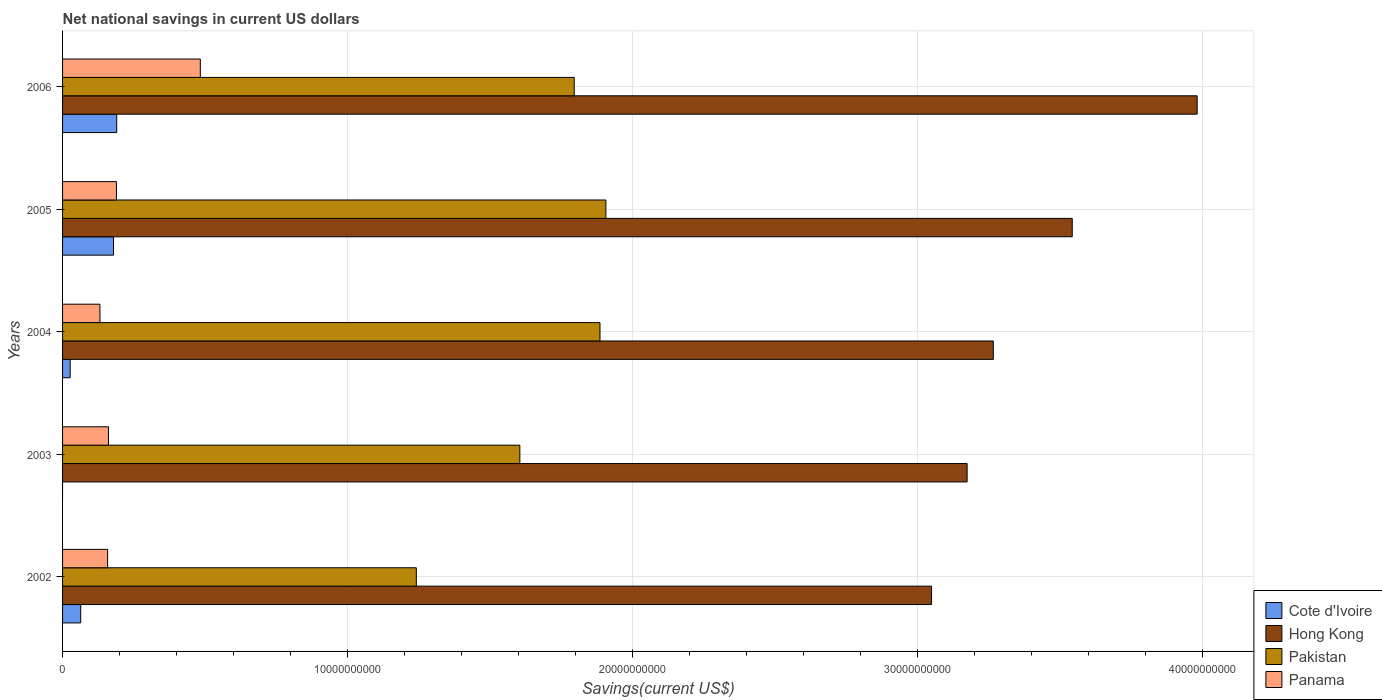How many different coloured bars are there?
Offer a terse response. 4. Are the number of bars per tick equal to the number of legend labels?
Give a very brief answer. No. Are the number of bars on each tick of the Y-axis equal?
Make the answer very short. No. How many bars are there on the 5th tick from the top?
Provide a succinct answer. 4. How many bars are there on the 3rd tick from the bottom?
Your answer should be very brief. 4. What is the label of the 1st group of bars from the top?
Give a very brief answer. 2006. In how many cases, is the number of bars for a given year not equal to the number of legend labels?
Offer a terse response. 1. What is the net national savings in Cote d'Ivoire in 2004?
Ensure brevity in your answer.  2.67e+08. Across all years, what is the maximum net national savings in Hong Kong?
Keep it short and to the point. 3.98e+1. Across all years, what is the minimum net national savings in Panama?
Your answer should be compact. 1.31e+09. What is the total net national savings in Panama in the graph?
Offer a very short reply. 1.12e+1. What is the difference between the net national savings in Panama in 2002 and that in 2003?
Offer a very short reply. -3.04e+07. What is the difference between the net national savings in Cote d'Ivoire in 2005 and the net national savings in Pakistan in 2003?
Make the answer very short. -1.43e+1. What is the average net national savings in Hong Kong per year?
Your answer should be very brief. 3.40e+1. In the year 2005, what is the difference between the net national savings in Pakistan and net national savings in Hong Kong?
Your answer should be very brief. -1.64e+1. In how many years, is the net national savings in Panama greater than 24000000000 US$?
Ensure brevity in your answer.  0. What is the ratio of the net national savings in Pakistan in 2005 to that in 2006?
Your answer should be very brief. 1.06. Is the net national savings in Pakistan in 2005 less than that in 2006?
Ensure brevity in your answer.  No. Is the difference between the net national savings in Pakistan in 2005 and 2006 greater than the difference between the net national savings in Hong Kong in 2005 and 2006?
Provide a short and direct response. Yes. What is the difference between the highest and the second highest net national savings in Panama?
Keep it short and to the point. 2.94e+09. What is the difference between the highest and the lowest net national savings in Cote d'Ivoire?
Give a very brief answer. 1.90e+09. Is it the case that in every year, the sum of the net national savings in Hong Kong and net national savings in Panama is greater than the sum of net national savings in Pakistan and net national savings in Cote d'Ivoire?
Make the answer very short. No. How many bars are there?
Offer a very short reply. 19. Are all the bars in the graph horizontal?
Make the answer very short. Yes. How many years are there in the graph?
Your response must be concise. 5. What is the difference between two consecutive major ticks on the X-axis?
Ensure brevity in your answer.  1.00e+1. Are the values on the major ticks of X-axis written in scientific E-notation?
Give a very brief answer. No. Does the graph contain any zero values?
Offer a very short reply. Yes. Does the graph contain grids?
Provide a short and direct response. Yes. How are the legend labels stacked?
Ensure brevity in your answer.  Vertical. What is the title of the graph?
Offer a very short reply. Net national savings in current US dollars. What is the label or title of the X-axis?
Offer a terse response. Savings(current US$). What is the Savings(current US$) of Cote d'Ivoire in 2002?
Provide a succinct answer. 6.36e+08. What is the Savings(current US$) in Hong Kong in 2002?
Give a very brief answer. 3.05e+1. What is the Savings(current US$) of Pakistan in 2002?
Offer a terse response. 1.24e+1. What is the Savings(current US$) in Panama in 2002?
Make the answer very short. 1.58e+09. What is the Savings(current US$) in Cote d'Ivoire in 2003?
Provide a succinct answer. 0. What is the Savings(current US$) in Hong Kong in 2003?
Provide a short and direct response. 3.17e+1. What is the Savings(current US$) of Pakistan in 2003?
Your answer should be very brief. 1.60e+1. What is the Savings(current US$) of Panama in 2003?
Provide a succinct answer. 1.61e+09. What is the Savings(current US$) of Cote d'Ivoire in 2004?
Provide a short and direct response. 2.67e+08. What is the Savings(current US$) of Hong Kong in 2004?
Make the answer very short. 3.27e+1. What is the Savings(current US$) in Pakistan in 2004?
Your answer should be compact. 1.89e+1. What is the Savings(current US$) in Panama in 2004?
Keep it short and to the point. 1.31e+09. What is the Savings(current US$) in Cote d'Ivoire in 2005?
Your answer should be compact. 1.79e+09. What is the Savings(current US$) of Hong Kong in 2005?
Ensure brevity in your answer.  3.54e+1. What is the Savings(current US$) in Pakistan in 2005?
Provide a short and direct response. 1.91e+1. What is the Savings(current US$) in Panama in 2005?
Provide a succinct answer. 1.89e+09. What is the Savings(current US$) of Cote d'Ivoire in 2006?
Ensure brevity in your answer.  1.90e+09. What is the Savings(current US$) in Hong Kong in 2006?
Ensure brevity in your answer.  3.98e+1. What is the Savings(current US$) in Pakistan in 2006?
Make the answer very short. 1.79e+1. What is the Savings(current US$) of Panama in 2006?
Your answer should be very brief. 4.83e+09. Across all years, what is the maximum Savings(current US$) in Cote d'Ivoire?
Offer a very short reply. 1.90e+09. Across all years, what is the maximum Savings(current US$) in Hong Kong?
Offer a terse response. 3.98e+1. Across all years, what is the maximum Savings(current US$) of Pakistan?
Make the answer very short. 1.91e+1. Across all years, what is the maximum Savings(current US$) in Panama?
Provide a short and direct response. 4.83e+09. Across all years, what is the minimum Savings(current US$) of Cote d'Ivoire?
Offer a very short reply. 0. Across all years, what is the minimum Savings(current US$) in Hong Kong?
Provide a short and direct response. 3.05e+1. Across all years, what is the minimum Savings(current US$) of Pakistan?
Offer a very short reply. 1.24e+1. Across all years, what is the minimum Savings(current US$) of Panama?
Your answer should be compact. 1.31e+09. What is the total Savings(current US$) of Cote d'Ivoire in the graph?
Give a very brief answer. 4.59e+09. What is the total Savings(current US$) of Hong Kong in the graph?
Provide a short and direct response. 1.70e+11. What is the total Savings(current US$) in Pakistan in the graph?
Offer a very short reply. 8.43e+1. What is the total Savings(current US$) of Panama in the graph?
Ensure brevity in your answer.  1.12e+1. What is the difference between the Savings(current US$) in Hong Kong in 2002 and that in 2003?
Give a very brief answer. -1.25e+09. What is the difference between the Savings(current US$) of Pakistan in 2002 and that in 2003?
Offer a very short reply. -3.63e+09. What is the difference between the Savings(current US$) of Panama in 2002 and that in 2003?
Provide a succinct answer. -3.04e+07. What is the difference between the Savings(current US$) of Cote d'Ivoire in 2002 and that in 2004?
Your answer should be compact. 3.69e+08. What is the difference between the Savings(current US$) of Hong Kong in 2002 and that in 2004?
Keep it short and to the point. -2.17e+09. What is the difference between the Savings(current US$) of Pakistan in 2002 and that in 2004?
Your answer should be very brief. -6.44e+09. What is the difference between the Savings(current US$) of Panama in 2002 and that in 2004?
Provide a succinct answer. 2.68e+08. What is the difference between the Savings(current US$) of Cote d'Ivoire in 2002 and that in 2005?
Offer a terse response. -1.15e+09. What is the difference between the Savings(current US$) of Hong Kong in 2002 and that in 2005?
Make the answer very short. -4.93e+09. What is the difference between the Savings(current US$) in Pakistan in 2002 and that in 2005?
Ensure brevity in your answer.  -6.65e+09. What is the difference between the Savings(current US$) in Panama in 2002 and that in 2005?
Offer a terse response. -3.10e+08. What is the difference between the Savings(current US$) in Cote d'Ivoire in 2002 and that in 2006?
Offer a very short reply. -1.26e+09. What is the difference between the Savings(current US$) of Hong Kong in 2002 and that in 2006?
Keep it short and to the point. -9.32e+09. What is the difference between the Savings(current US$) of Pakistan in 2002 and that in 2006?
Make the answer very short. -5.54e+09. What is the difference between the Savings(current US$) in Panama in 2002 and that in 2006?
Offer a terse response. -3.25e+09. What is the difference between the Savings(current US$) in Hong Kong in 2003 and that in 2004?
Your response must be concise. -9.20e+08. What is the difference between the Savings(current US$) in Pakistan in 2003 and that in 2004?
Your answer should be very brief. -2.81e+09. What is the difference between the Savings(current US$) of Panama in 2003 and that in 2004?
Offer a very short reply. 2.99e+08. What is the difference between the Savings(current US$) in Hong Kong in 2003 and that in 2005?
Keep it short and to the point. -3.69e+09. What is the difference between the Savings(current US$) of Pakistan in 2003 and that in 2005?
Keep it short and to the point. -3.02e+09. What is the difference between the Savings(current US$) of Panama in 2003 and that in 2005?
Make the answer very short. -2.80e+08. What is the difference between the Savings(current US$) of Hong Kong in 2003 and that in 2006?
Give a very brief answer. -8.07e+09. What is the difference between the Savings(current US$) in Pakistan in 2003 and that in 2006?
Provide a succinct answer. -1.91e+09. What is the difference between the Savings(current US$) of Panama in 2003 and that in 2006?
Your answer should be very brief. -3.22e+09. What is the difference between the Savings(current US$) of Cote d'Ivoire in 2004 and that in 2005?
Provide a succinct answer. -1.52e+09. What is the difference between the Savings(current US$) in Hong Kong in 2004 and that in 2005?
Provide a succinct answer. -2.77e+09. What is the difference between the Savings(current US$) in Pakistan in 2004 and that in 2005?
Your response must be concise. -2.06e+08. What is the difference between the Savings(current US$) in Panama in 2004 and that in 2005?
Offer a very short reply. -5.78e+08. What is the difference between the Savings(current US$) in Cote d'Ivoire in 2004 and that in 2006?
Keep it short and to the point. -1.63e+09. What is the difference between the Savings(current US$) of Hong Kong in 2004 and that in 2006?
Your response must be concise. -7.15e+09. What is the difference between the Savings(current US$) of Pakistan in 2004 and that in 2006?
Keep it short and to the point. 9.04e+08. What is the difference between the Savings(current US$) of Panama in 2004 and that in 2006?
Offer a terse response. -3.52e+09. What is the difference between the Savings(current US$) of Cote d'Ivoire in 2005 and that in 2006?
Your response must be concise. -1.12e+08. What is the difference between the Savings(current US$) of Hong Kong in 2005 and that in 2006?
Your answer should be compact. -4.38e+09. What is the difference between the Savings(current US$) of Pakistan in 2005 and that in 2006?
Provide a succinct answer. 1.11e+09. What is the difference between the Savings(current US$) of Panama in 2005 and that in 2006?
Offer a terse response. -2.94e+09. What is the difference between the Savings(current US$) in Cote d'Ivoire in 2002 and the Savings(current US$) in Hong Kong in 2003?
Your response must be concise. -3.11e+1. What is the difference between the Savings(current US$) of Cote d'Ivoire in 2002 and the Savings(current US$) of Pakistan in 2003?
Make the answer very short. -1.54e+1. What is the difference between the Savings(current US$) of Cote d'Ivoire in 2002 and the Savings(current US$) of Panama in 2003?
Your response must be concise. -9.75e+08. What is the difference between the Savings(current US$) in Hong Kong in 2002 and the Savings(current US$) in Pakistan in 2003?
Provide a succinct answer. 1.44e+1. What is the difference between the Savings(current US$) of Hong Kong in 2002 and the Savings(current US$) of Panama in 2003?
Give a very brief answer. 2.89e+1. What is the difference between the Savings(current US$) of Pakistan in 2002 and the Savings(current US$) of Panama in 2003?
Offer a terse response. 1.08e+1. What is the difference between the Savings(current US$) in Cote d'Ivoire in 2002 and the Savings(current US$) in Hong Kong in 2004?
Ensure brevity in your answer.  -3.20e+1. What is the difference between the Savings(current US$) of Cote d'Ivoire in 2002 and the Savings(current US$) of Pakistan in 2004?
Your answer should be very brief. -1.82e+1. What is the difference between the Savings(current US$) in Cote d'Ivoire in 2002 and the Savings(current US$) in Panama in 2004?
Provide a short and direct response. -6.76e+08. What is the difference between the Savings(current US$) of Hong Kong in 2002 and the Savings(current US$) of Pakistan in 2004?
Provide a short and direct response. 1.16e+1. What is the difference between the Savings(current US$) of Hong Kong in 2002 and the Savings(current US$) of Panama in 2004?
Provide a succinct answer. 2.92e+1. What is the difference between the Savings(current US$) of Pakistan in 2002 and the Savings(current US$) of Panama in 2004?
Provide a short and direct response. 1.11e+1. What is the difference between the Savings(current US$) of Cote d'Ivoire in 2002 and the Savings(current US$) of Hong Kong in 2005?
Provide a succinct answer. -3.48e+1. What is the difference between the Savings(current US$) in Cote d'Ivoire in 2002 and the Savings(current US$) in Pakistan in 2005?
Ensure brevity in your answer.  -1.84e+1. What is the difference between the Savings(current US$) of Cote d'Ivoire in 2002 and the Savings(current US$) of Panama in 2005?
Your response must be concise. -1.25e+09. What is the difference between the Savings(current US$) in Hong Kong in 2002 and the Savings(current US$) in Pakistan in 2005?
Keep it short and to the point. 1.14e+1. What is the difference between the Savings(current US$) in Hong Kong in 2002 and the Savings(current US$) in Panama in 2005?
Provide a succinct answer. 2.86e+1. What is the difference between the Savings(current US$) in Pakistan in 2002 and the Savings(current US$) in Panama in 2005?
Make the answer very short. 1.05e+1. What is the difference between the Savings(current US$) of Cote d'Ivoire in 2002 and the Savings(current US$) of Hong Kong in 2006?
Offer a very short reply. -3.92e+1. What is the difference between the Savings(current US$) in Cote d'Ivoire in 2002 and the Savings(current US$) in Pakistan in 2006?
Your response must be concise. -1.73e+1. What is the difference between the Savings(current US$) in Cote d'Ivoire in 2002 and the Savings(current US$) in Panama in 2006?
Ensure brevity in your answer.  -4.20e+09. What is the difference between the Savings(current US$) of Hong Kong in 2002 and the Savings(current US$) of Pakistan in 2006?
Provide a short and direct response. 1.25e+1. What is the difference between the Savings(current US$) of Hong Kong in 2002 and the Savings(current US$) of Panama in 2006?
Provide a short and direct response. 2.57e+1. What is the difference between the Savings(current US$) of Pakistan in 2002 and the Savings(current US$) of Panama in 2006?
Your answer should be very brief. 7.58e+09. What is the difference between the Savings(current US$) in Hong Kong in 2003 and the Savings(current US$) in Pakistan in 2004?
Make the answer very short. 1.29e+1. What is the difference between the Savings(current US$) of Hong Kong in 2003 and the Savings(current US$) of Panama in 2004?
Your response must be concise. 3.04e+1. What is the difference between the Savings(current US$) in Pakistan in 2003 and the Savings(current US$) in Panama in 2004?
Offer a very short reply. 1.47e+1. What is the difference between the Savings(current US$) in Hong Kong in 2003 and the Savings(current US$) in Pakistan in 2005?
Your response must be concise. 1.27e+1. What is the difference between the Savings(current US$) of Hong Kong in 2003 and the Savings(current US$) of Panama in 2005?
Offer a terse response. 2.98e+1. What is the difference between the Savings(current US$) of Pakistan in 2003 and the Savings(current US$) of Panama in 2005?
Provide a succinct answer. 1.42e+1. What is the difference between the Savings(current US$) in Hong Kong in 2003 and the Savings(current US$) in Pakistan in 2006?
Ensure brevity in your answer.  1.38e+1. What is the difference between the Savings(current US$) in Hong Kong in 2003 and the Savings(current US$) in Panama in 2006?
Your answer should be very brief. 2.69e+1. What is the difference between the Savings(current US$) of Pakistan in 2003 and the Savings(current US$) of Panama in 2006?
Provide a succinct answer. 1.12e+1. What is the difference between the Savings(current US$) in Cote d'Ivoire in 2004 and the Savings(current US$) in Hong Kong in 2005?
Offer a terse response. -3.52e+1. What is the difference between the Savings(current US$) in Cote d'Ivoire in 2004 and the Savings(current US$) in Pakistan in 2005?
Ensure brevity in your answer.  -1.88e+1. What is the difference between the Savings(current US$) of Cote d'Ivoire in 2004 and the Savings(current US$) of Panama in 2005?
Provide a succinct answer. -1.62e+09. What is the difference between the Savings(current US$) in Hong Kong in 2004 and the Savings(current US$) in Pakistan in 2005?
Your answer should be very brief. 1.36e+1. What is the difference between the Savings(current US$) in Hong Kong in 2004 and the Savings(current US$) in Panama in 2005?
Your answer should be compact. 3.08e+1. What is the difference between the Savings(current US$) of Pakistan in 2004 and the Savings(current US$) of Panama in 2005?
Offer a very short reply. 1.70e+1. What is the difference between the Savings(current US$) of Cote d'Ivoire in 2004 and the Savings(current US$) of Hong Kong in 2006?
Give a very brief answer. -3.95e+1. What is the difference between the Savings(current US$) of Cote d'Ivoire in 2004 and the Savings(current US$) of Pakistan in 2006?
Give a very brief answer. -1.77e+1. What is the difference between the Savings(current US$) in Cote d'Ivoire in 2004 and the Savings(current US$) in Panama in 2006?
Offer a very short reply. -4.56e+09. What is the difference between the Savings(current US$) in Hong Kong in 2004 and the Savings(current US$) in Pakistan in 2006?
Give a very brief answer. 1.47e+1. What is the difference between the Savings(current US$) in Hong Kong in 2004 and the Savings(current US$) in Panama in 2006?
Make the answer very short. 2.78e+1. What is the difference between the Savings(current US$) of Pakistan in 2004 and the Savings(current US$) of Panama in 2006?
Offer a very short reply. 1.40e+1. What is the difference between the Savings(current US$) of Cote d'Ivoire in 2005 and the Savings(current US$) of Hong Kong in 2006?
Provide a succinct answer. -3.80e+1. What is the difference between the Savings(current US$) in Cote d'Ivoire in 2005 and the Savings(current US$) in Pakistan in 2006?
Your answer should be very brief. -1.62e+1. What is the difference between the Savings(current US$) of Cote d'Ivoire in 2005 and the Savings(current US$) of Panama in 2006?
Your answer should be very brief. -3.04e+09. What is the difference between the Savings(current US$) in Hong Kong in 2005 and the Savings(current US$) in Pakistan in 2006?
Provide a succinct answer. 1.75e+1. What is the difference between the Savings(current US$) of Hong Kong in 2005 and the Savings(current US$) of Panama in 2006?
Offer a terse response. 3.06e+1. What is the difference between the Savings(current US$) in Pakistan in 2005 and the Savings(current US$) in Panama in 2006?
Your answer should be compact. 1.42e+1. What is the average Savings(current US$) of Cote d'Ivoire per year?
Ensure brevity in your answer.  9.18e+08. What is the average Savings(current US$) in Hong Kong per year?
Your response must be concise. 3.40e+1. What is the average Savings(current US$) of Pakistan per year?
Your answer should be compact. 1.69e+1. What is the average Savings(current US$) in Panama per year?
Make the answer very short. 2.24e+09. In the year 2002, what is the difference between the Savings(current US$) in Cote d'Ivoire and Savings(current US$) in Hong Kong?
Your answer should be compact. -2.98e+1. In the year 2002, what is the difference between the Savings(current US$) of Cote d'Ivoire and Savings(current US$) of Pakistan?
Ensure brevity in your answer.  -1.18e+1. In the year 2002, what is the difference between the Savings(current US$) in Cote d'Ivoire and Savings(current US$) in Panama?
Give a very brief answer. -9.44e+08. In the year 2002, what is the difference between the Savings(current US$) in Hong Kong and Savings(current US$) in Pakistan?
Offer a terse response. 1.81e+1. In the year 2002, what is the difference between the Savings(current US$) in Hong Kong and Savings(current US$) in Panama?
Ensure brevity in your answer.  2.89e+1. In the year 2002, what is the difference between the Savings(current US$) of Pakistan and Savings(current US$) of Panama?
Keep it short and to the point. 1.08e+1. In the year 2003, what is the difference between the Savings(current US$) of Hong Kong and Savings(current US$) of Pakistan?
Your answer should be very brief. 1.57e+1. In the year 2003, what is the difference between the Savings(current US$) of Hong Kong and Savings(current US$) of Panama?
Ensure brevity in your answer.  3.01e+1. In the year 2003, what is the difference between the Savings(current US$) in Pakistan and Savings(current US$) in Panama?
Provide a short and direct response. 1.44e+1. In the year 2004, what is the difference between the Savings(current US$) of Cote d'Ivoire and Savings(current US$) of Hong Kong?
Provide a succinct answer. -3.24e+1. In the year 2004, what is the difference between the Savings(current US$) of Cote d'Ivoire and Savings(current US$) of Pakistan?
Offer a terse response. -1.86e+1. In the year 2004, what is the difference between the Savings(current US$) in Cote d'Ivoire and Savings(current US$) in Panama?
Your answer should be compact. -1.04e+09. In the year 2004, what is the difference between the Savings(current US$) in Hong Kong and Savings(current US$) in Pakistan?
Offer a terse response. 1.38e+1. In the year 2004, what is the difference between the Savings(current US$) of Hong Kong and Savings(current US$) of Panama?
Keep it short and to the point. 3.13e+1. In the year 2004, what is the difference between the Savings(current US$) of Pakistan and Savings(current US$) of Panama?
Your answer should be compact. 1.75e+1. In the year 2005, what is the difference between the Savings(current US$) in Cote d'Ivoire and Savings(current US$) in Hong Kong?
Your answer should be very brief. -3.36e+1. In the year 2005, what is the difference between the Savings(current US$) of Cote d'Ivoire and Savings(current US$) of Pakistan?
Offer a terse response. -1.73e+1. In the year 2005, what is the difference between the Savings(current US$) in Cote d'Ivoire and Savings(current US$) in Panama?
Keep it short and to the point. -1.03e+08. In the year 2005, what is the difference between the Savings(current US$) in Hong Kong and Savings(current US$) in Pakistan?
Offer a very short reply. 1.64e+1. In the year 2005, what is the difference between the Savings(current US$) of Hong Kong and Savings(current US$) of Panama?
Provide a short and direct response. 3.35e+1. In the year 2005, what is the difference between the Savings(current US$) of Pakistan and Savings(current US$) of Panama?
Offer a terse response. 1.72e+1. In the year 2006, what is the difference between the Savings(current US$) in Cote d'Ivoire and Savings(current US$) in Hong Kong?
Keep it short and to the point. -3.79e+1. In the year 2006, what is the difference between the Savings(current US$) of Cote d'Ivoire and Savings(current US$) of Pakistan?
Provide a succinct answer. -1.60e+1. In the year 2006, what is the difference between the Savings(current US$) of Cote d'Ivoire and Savings(current US$) of Panama?
Your answer should be very brief. -2.93e+09. In the year 2006, what is the difference between the Savings(current US$) in Hong Kong and Savings(current US$) in Pakistan?
Offer a very short reply. 2.19e+1. In the year 2006, what is the difference between the Savings(current US$) in Hong Kong and Savings(current US$) in Panama?
Provide a short and direct response. 3.50e+1. In the year 2006, what is the difference between the Savings(current US$) of Pakistan and Savings(current US$) of Panama?
Your answer should be compact. 1.31e+1. What is the ratio of the Savings(current US$) of Hong Kong in 2002 to that in 2003?
Offer a terse response. 0.96. What is the ratio of the Savings(current US$) of Pakistan in 2002 to that in 2003?
Make the answer very short. 0.77. What is the ratio of the Savings(current US$) of Panama in 2002 to that in 2003?
Your answer should be very brief. 0.98. What is the ratio of the Savings(current US$) of Cote d'Ivoire in 2002 to that in 2004?
Provide a short and direct response. 2.38. What is the ratio of the Savings(current US$) of Hong Kong in 2002 to that in 2004?
Ensure brevity in your answer.  0.93. What is the ratio of the Savings(current US$) of Pakistan in 2002 to that in 2004?
Keep it short and to the point. 0.66. What is the ratio of the Savings(current US$) in Panama in 2002 to that in 2004?
Ensure brevity in your answer.  1.2. What is the ratio of the Savings(current US$) in Cote d'Ivoire in 2002 to that in 2005?
Provide a short and direct response. 0.36. What is the ratio of the Savings(current US$) in Hong Kong in 2002 to that in 2005?
Provide a short and direct response. 0.86. What is the ratio of the Savings(current US$) in Pakistan in 2002 to that in 2005?
Provide a succinct answer. 0.65. What is the ratio of the Savings(current US$) of Panama in 2002 to that in 2005?
Offer a very short reply. 0.84. What is the ratio of the Savings(current US$) of Cote d'Ivoire in 2002 to that in 2006?
Offer a terse response. 0.33. What is the ratio of the Savings(current US$) in Hong Kong in 2002 to that in 2006?
Make the answer very short. 0.77. What is the ratio of the Savings(current US$) of Pakistan in 2002 to that in 2006?
Your answer should be compact. 0.69. What is the ratio of the Savings(current US$) of Panama in 2002 to that in 2006?
Make the answer very short. 0.33. What is the ratio of the Savings(current US$) in Hong Kong in 2003 to that in 2004?
Provide a short and direct response. 0.97. What is the ratio of the Savings(current US$) of Pakistan in 2003 to that in 2004?
Your answer should be very brief. 0.85. What is the ratio of the Savings(current US$) of Panama in 2003 to that in 2004?
Keep it short and to the point. 1.23. What is the ratio of the Savings(current US$) in Hong Kong in 2003 to that in 2005?
Make the answer very short. 0.9. What is the ratio of the Savings(current US$) in Pakistan in 2003 to that in 2005?
Ensure brevity in your answer.  0.84. What is the ratio of the Savings(current US$) in Panama in 2003 to that in 2005?
Provide a short and direct response. 0.85. What is the ratio of the Savings(current US$) of Hong Kong in 2003 to that in 2006?
Make the answer very short. 0.8. What is the ratio of the Savings(current US$) of Pakistan in 2003 to that in 2006?
Provide a succinct answer. 0.89. What is the ratio of the Savings(current US$) in Cote d'Ivoire in 2004 to that in 2005?
Your answer should be compact. 0.15. What is the ratio of the Savings(current US$) in Hong Kong in 2004 to that in 2005?
Offer a terse response. 0.92. What is the ratio of the Savings(current US$) of Pakistan in 2004 to that in 2005?
Your answer should be very brief. 0.99. What is the ratio of the Savings(current US$) of Panama in 2004 to that in 2005?
Your response must be concise. 0.69. What is the ratio of the Savings(current US$) in Cote d'Ivoire in 2004 to that in 2006?
Provide a succinct answer. 0.14. What is the ratio of the Savings(current US$) in Hong Kong in 2004 to that in 2006?
Provide a short and direct response. 0.82. What is the ratio of the Savings(current US$) in Pakistan in 2004 to that in 2006?
Provide a short and direct response. 1.05. What is the ratio of the Savings(current US$) of Panama in 2004 to that in 2006?
Keep it short and to the point. 0.27. What is the ratio of the Savings(current US$) of Cote d'Ivoire in 2005 to that in 2006?
Ensure brevity in your answer.  0.94. What is the ratio of the Savings(current US$) in Hong Kong in 2005 to that in 2006?
Provide a succinct answer. 0.89. What is the ratio of the Savings(current US$) of Pakistan in 2005 to that in 2006?
Offer a terse response. 1.06. What is the ratio of the Savings(current US$) in Panama in 2005 to that in 2006?
Offer a very short reply. 0.39. What is the difference between the highest and the second highest Savings(current US$) in Cote d'Ivoire?
Provide a short and direct response. 1.12e+08. What is the difference between the highest and the second highest Savings(current US$) of Hong Kong?
Your answer should be compact. 4.38e+09. What is the difference between the highest and the second highest Savings(current US$) of Pakistan?
Offer a very short reply. 2.06e+08. What is the difference between the highest and the second highest Savings(current US$) of Panama?
Your response must be concise. 2.94e+09. What is the difference between the highest and the lowest Savings(current US$) in Cote d'Ivoire?
Your response must be concise. 1.90e+09. What is the difference between the highest and the lowest Savings(current US$) of Hong Kong?
Offer a terse response. 9.32e+09. What is the difference between the highest and the lowest Savings(current US$) in Pakistan?
Make the answer very short. 6.65e+09. What is the difference between the highest and the lowest Savings(current US$) in Panama?
Your answer should be compact. 3.52e+09. 